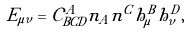<formula> <loc_0><loc_0><loc_500><loc_500>E _ { \mu \nu } = { \mathcal { C } } ^ { A } _ { B C D } n _ { A } n ^ { C } h _ { \mu } ^ { B } h _ { \nu } ^ { D } ,</formula> 